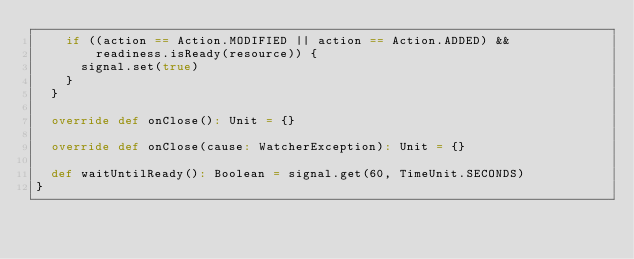<code> <loc_0><loc_0><loc_500><loc_500><_Scala_>    if ((action == Action.MODIFIED || action == Action.ADDED) &&
        readiness.isReady(resource)) {
      signal.set(true)
    }
  }

  override def onClose(): Unit = {}

  override def onClose(cause: WatcherException): Unit = {}

  def waitUntilReady(): Boolean = signal.get(60, TimeUnit.SECONDS)
}
</code> 